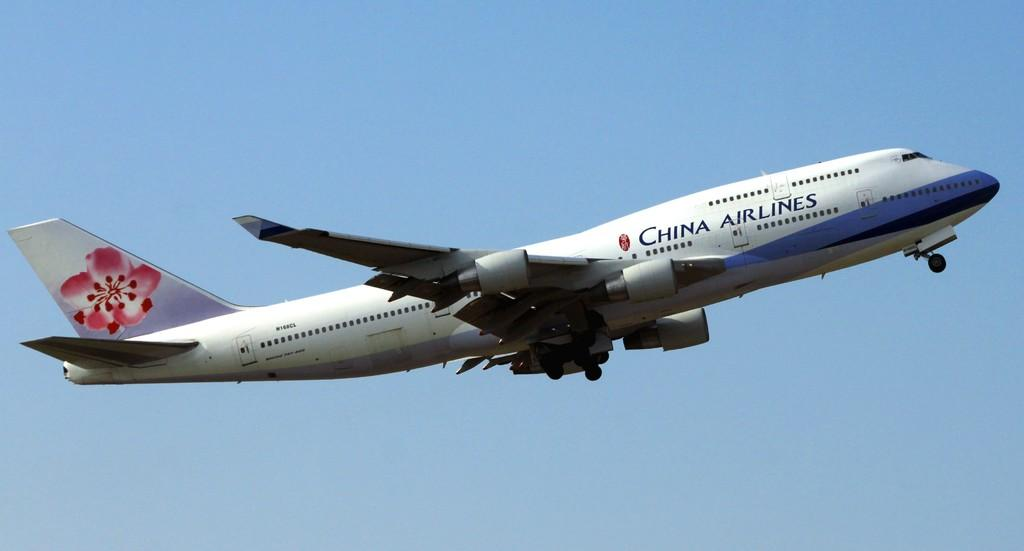Provide a one-sentence caption for the provided image. a China airlines jet in a very clear blue sky. 